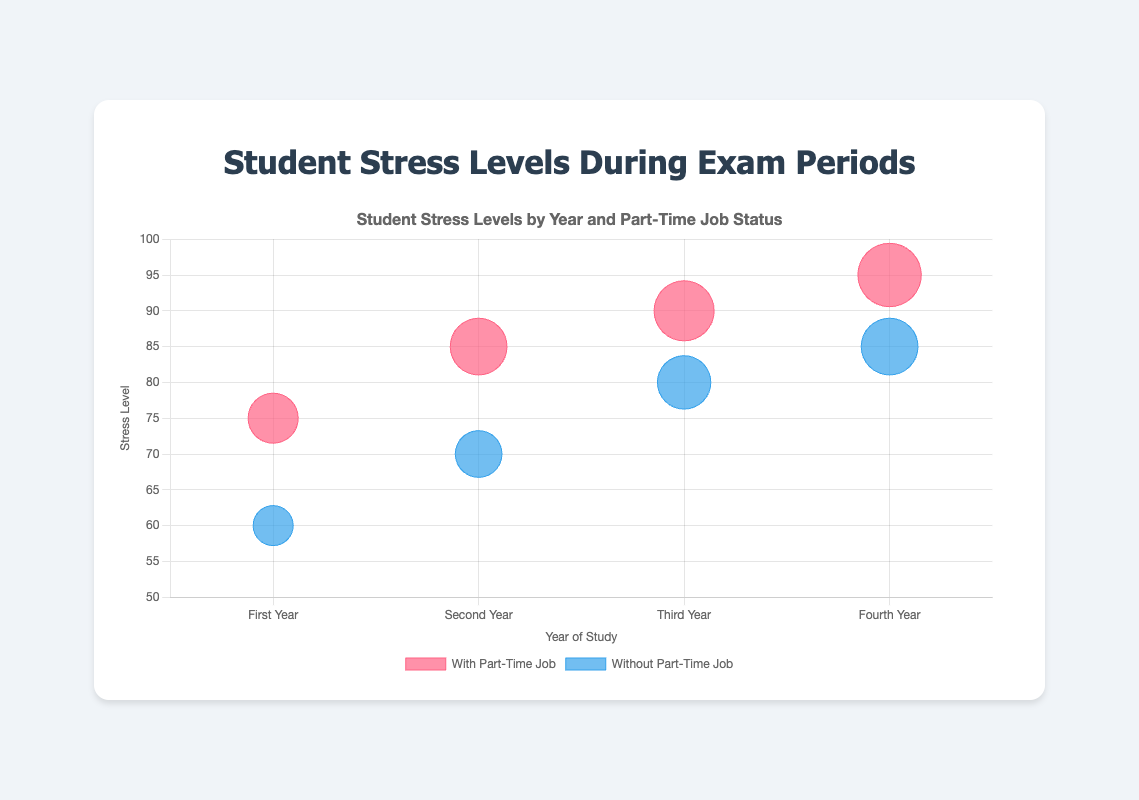What does the bubble chart's title indicate? The bubble chart's title is "Student Stress Levels by Year and Part-Time Job Status," which indicates that the chart shows the stress levels of university students during exam periods, segmented by their year of study and whether or not they have a part-time job.
Answer: Student Stress Levels by Year and Part-Time Job Status What are the axes representing in the bubble chart? The x-axis represents the "Year of Study" (ranging from First Year to Fourth Year), and the y-axis represents the "Stress Level" (scaled from 50 to 100).
Answer: Year of Study and Stress Level How many students with part-time jobs are depicted in the chart? Counting the number of bubbles in the dataset labeled as "With Part-Time Job" reveals the number of students. The chart has four students with part-time jobs.
Answer: 4 Which group appears to have the highest stress level? The group of students with part-time jobs during their Fourth Year has the highest stress level, indicated by the highest bubble position on the y-axis and the largest size (student: George Wilson with 95 stress level).
Answer: Fourth Year with Part-Time Job Is there a noticeable difference in stress levels between students with and without part-time jobs in their First Year? Comparing the y-axis positions for the first-year students with part-time jobs (75) and without part-time jobs (60) indicates that students with part-time jobs have higher stress levels.
Answer: Yes What's the average stress level of students in their Third Year? Average the stress levels of the Third Year students (90 for part-time and 80 for no part-time). (90 + 80) / 2 = 85.
Answer: 85 Which student has the lowest stress level, and what is it? By inspecting the chart, we identify the student with the lowest position on the y-axis. Bob Smith, a First Year student without a part-time job, exhibits the lowest stress level at 60.
Answer: Bob Smith with 60 Among students in their Second Year, who has a higher stress level and by how much? Comparing the y-axis positions, Charlie Brown (with part-time job) has a stress level of 85, while David Williams (without part-time job) has 70. The difference is 85 - 70 = 15.
Answer: Charlie Brown by 15 What is the trend of stress levels for students with part-time jobs from First to Fourth Year? Observing the y-axis positions and sizes of bubbles for students with part-time jobs from First Year (75) to Fourth Year (95), stress levels increase as the year of study progresses.
Answer: Increasing In which year do students without part-time jobs experience the highest stress levels, and what is that level? Checking the highest y-axis position among students without part-time jobs shows that Fourth Year students have the highest stress level at 85.
Answer: Fourth Year with 85 